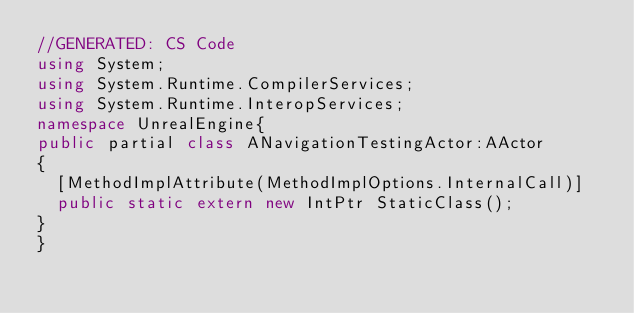<code> <loc_0><loc_0><loc_500><loc_500><_C#_>//GENERATED: CS Code
using System;
using System.Runtime.CompilerServices;
using System.Runtime.InteropServices;
namespace UnrealEngine{
public partial class ANavigationTestingActor:AActor 
{
	[MethodImplAttribute(MethodImplOptions.InternalCall)]
	public static extern new IntPtr StaticClass();
}
}
</code> 